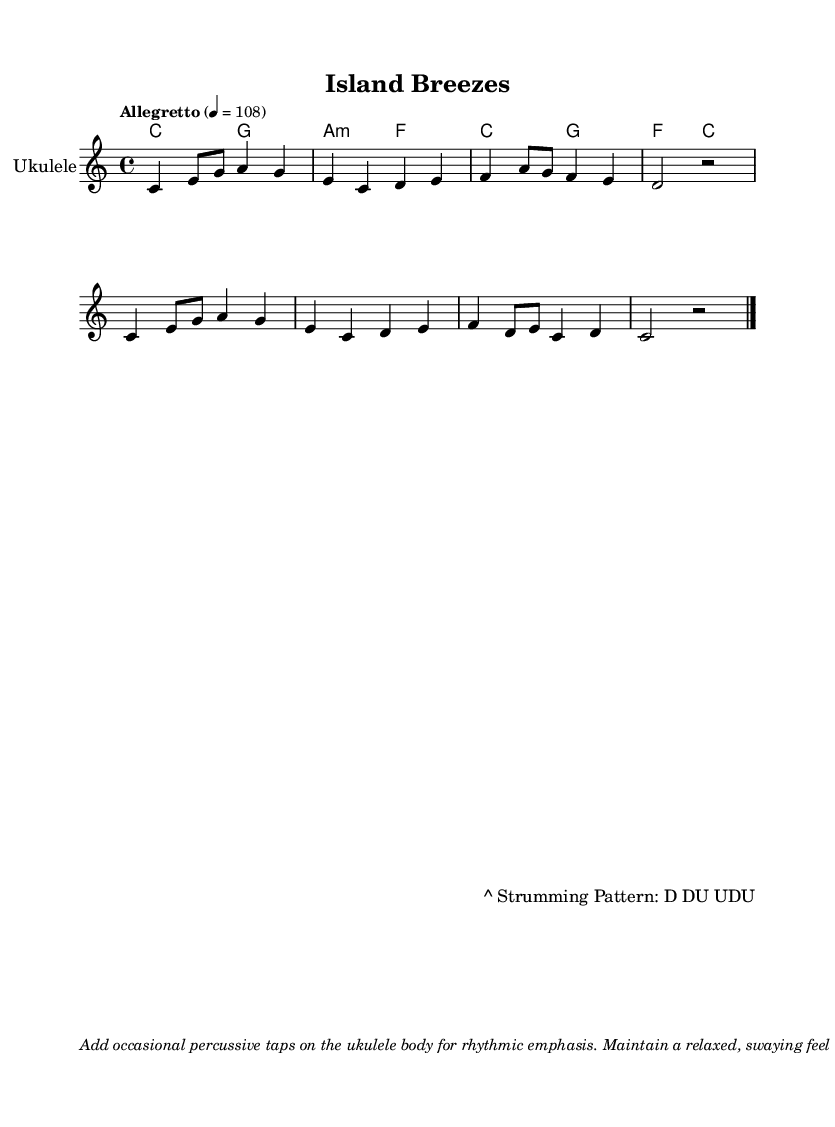What is the key signature of this music? The key signature is C major, which has no sharps or flats.
Answer: C major What is the time signature of this music? The time signature is indicated at the beginning of the piece, showing that there are four beats in each measure.
Answer: 4/4 What is the tempo marking for this piece? The tempo marking is specified in the score, indicating that the piece should be played at a speed of 108 beats per minute at an allegretto pace.
Answer: 108 How many measures are in the melody section? By counting the vertical lines, which separate measures in the score, one can see that there are a total of eight measures in the melody section.
Answer: 8 What is the strumming pattern indicated in the lyrics? The strumming pattern is described at the bottom of the lyrics section of the score and includes specific strokes used while playing.
Answer: D DU UDU What type of music does this piece represent? The piece is characterized by its instrumentation and style, being played on the ukulele with a laid-back feel typical of Polynesian or island music genres.
Answer: Polynesian 